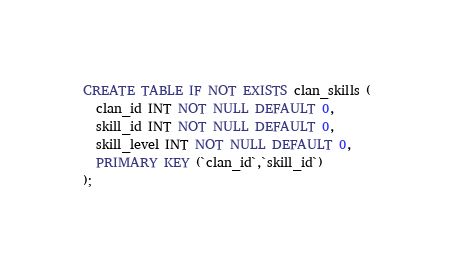Convert code to text. <code><loc_0><loc_0><loc_500><loc_500><_SQL_>CREATE TABLE IF NOT EXISTS clan_skills (
  clan_id INT NOT NULL DEFAULT 0,
  skill_id INT NOT NULL DEFAULT 0,
  skill_level INT NOT NULL DEFAULT 0,
  PRIMARY KEY (`clan_id`,`skill_id`)
);</code> 